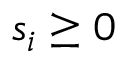Convert formula to latex. <formula><loc_0><loc_0><loc_500><loc_500>s _ { i } \geq 0</formula> 